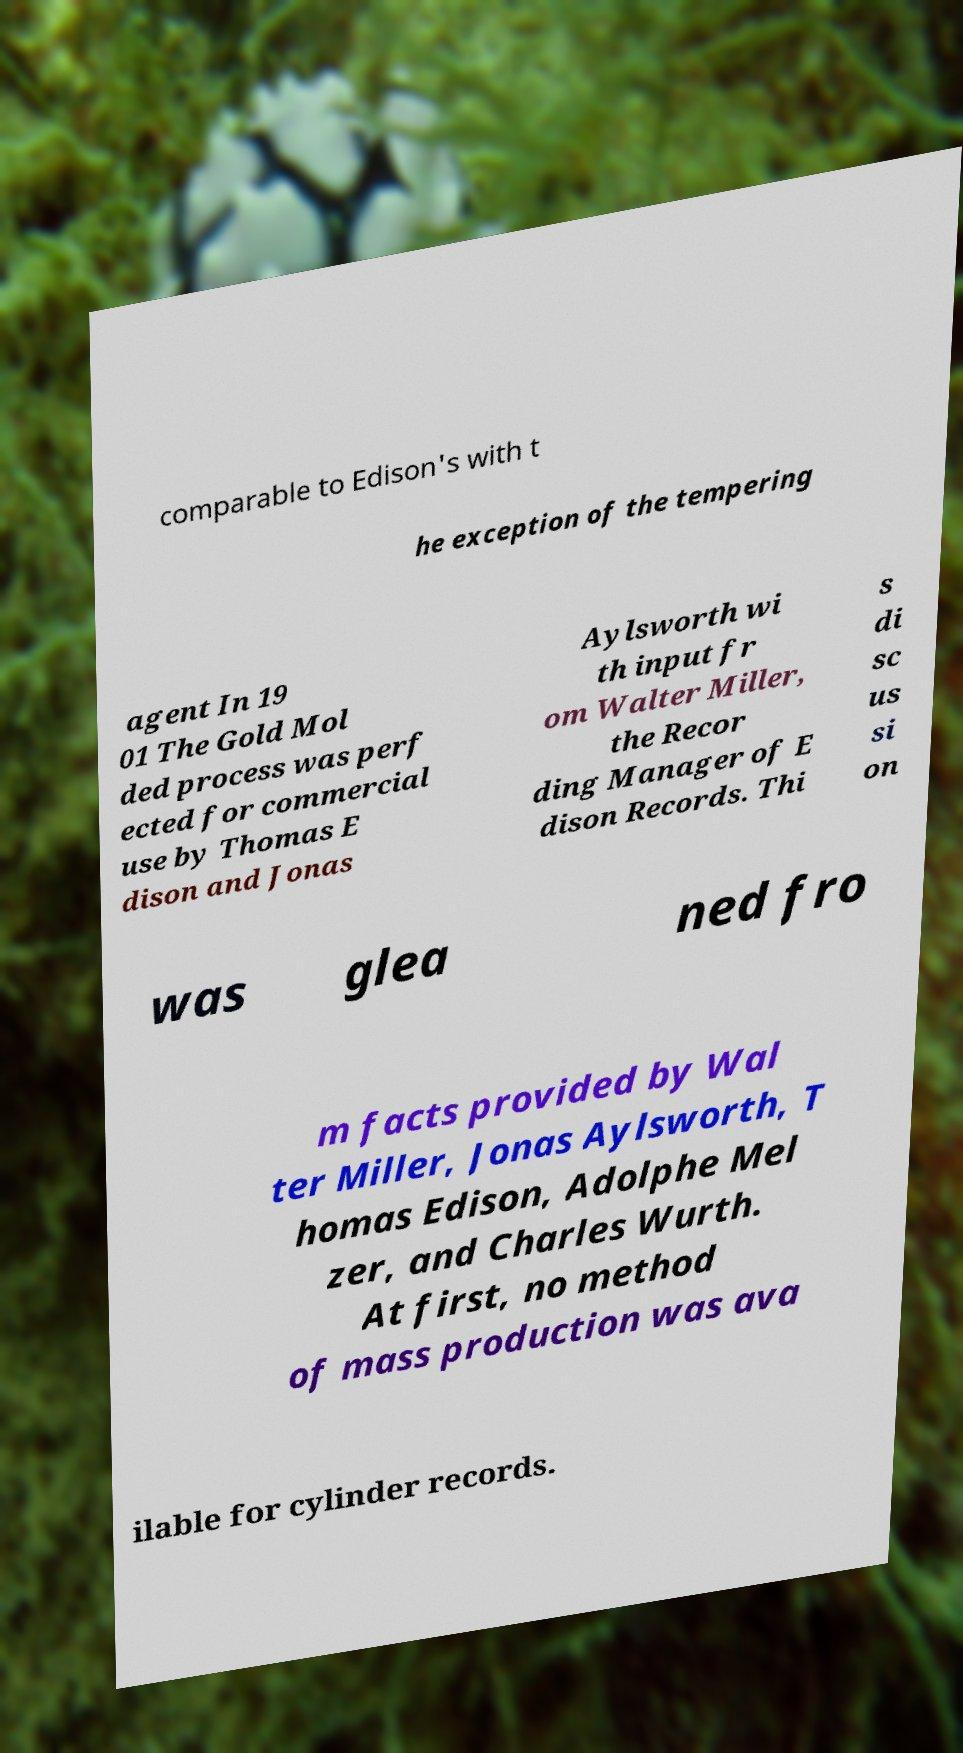Could you assist in decoding the text presented in this image and type it out clearly? comparable to Edison's with t he exception of the tempering agent In 19 01 The Gold Mol ded process was perf ected for commercial use by Thomas E dison and Jonas Aylsworth wi th input fr om Walter Miller, the Recor ding Manager of E dison Records. Thi s di sc us si on was glea ned fro m facts provided by Wal ter Miller, Jonas Aylsworth, T homas Edison, Adolphe Mel zer, and Charles Wurth. At first, no method of mass production was ava ilable for cylinder records. 